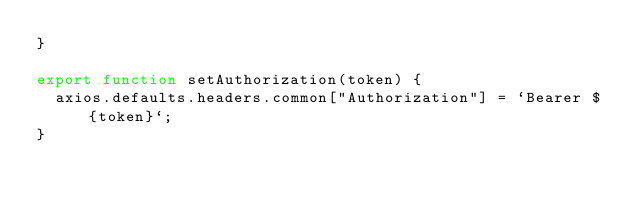Convert code to text. <code><loc_0><loc_0><loc_500><loc_500><_JavaScript_>}

export function setAuthorization(token) {
  axios.defaults.headers.common["Authorization"] = `Bearer ${token}`;
}
</code> 